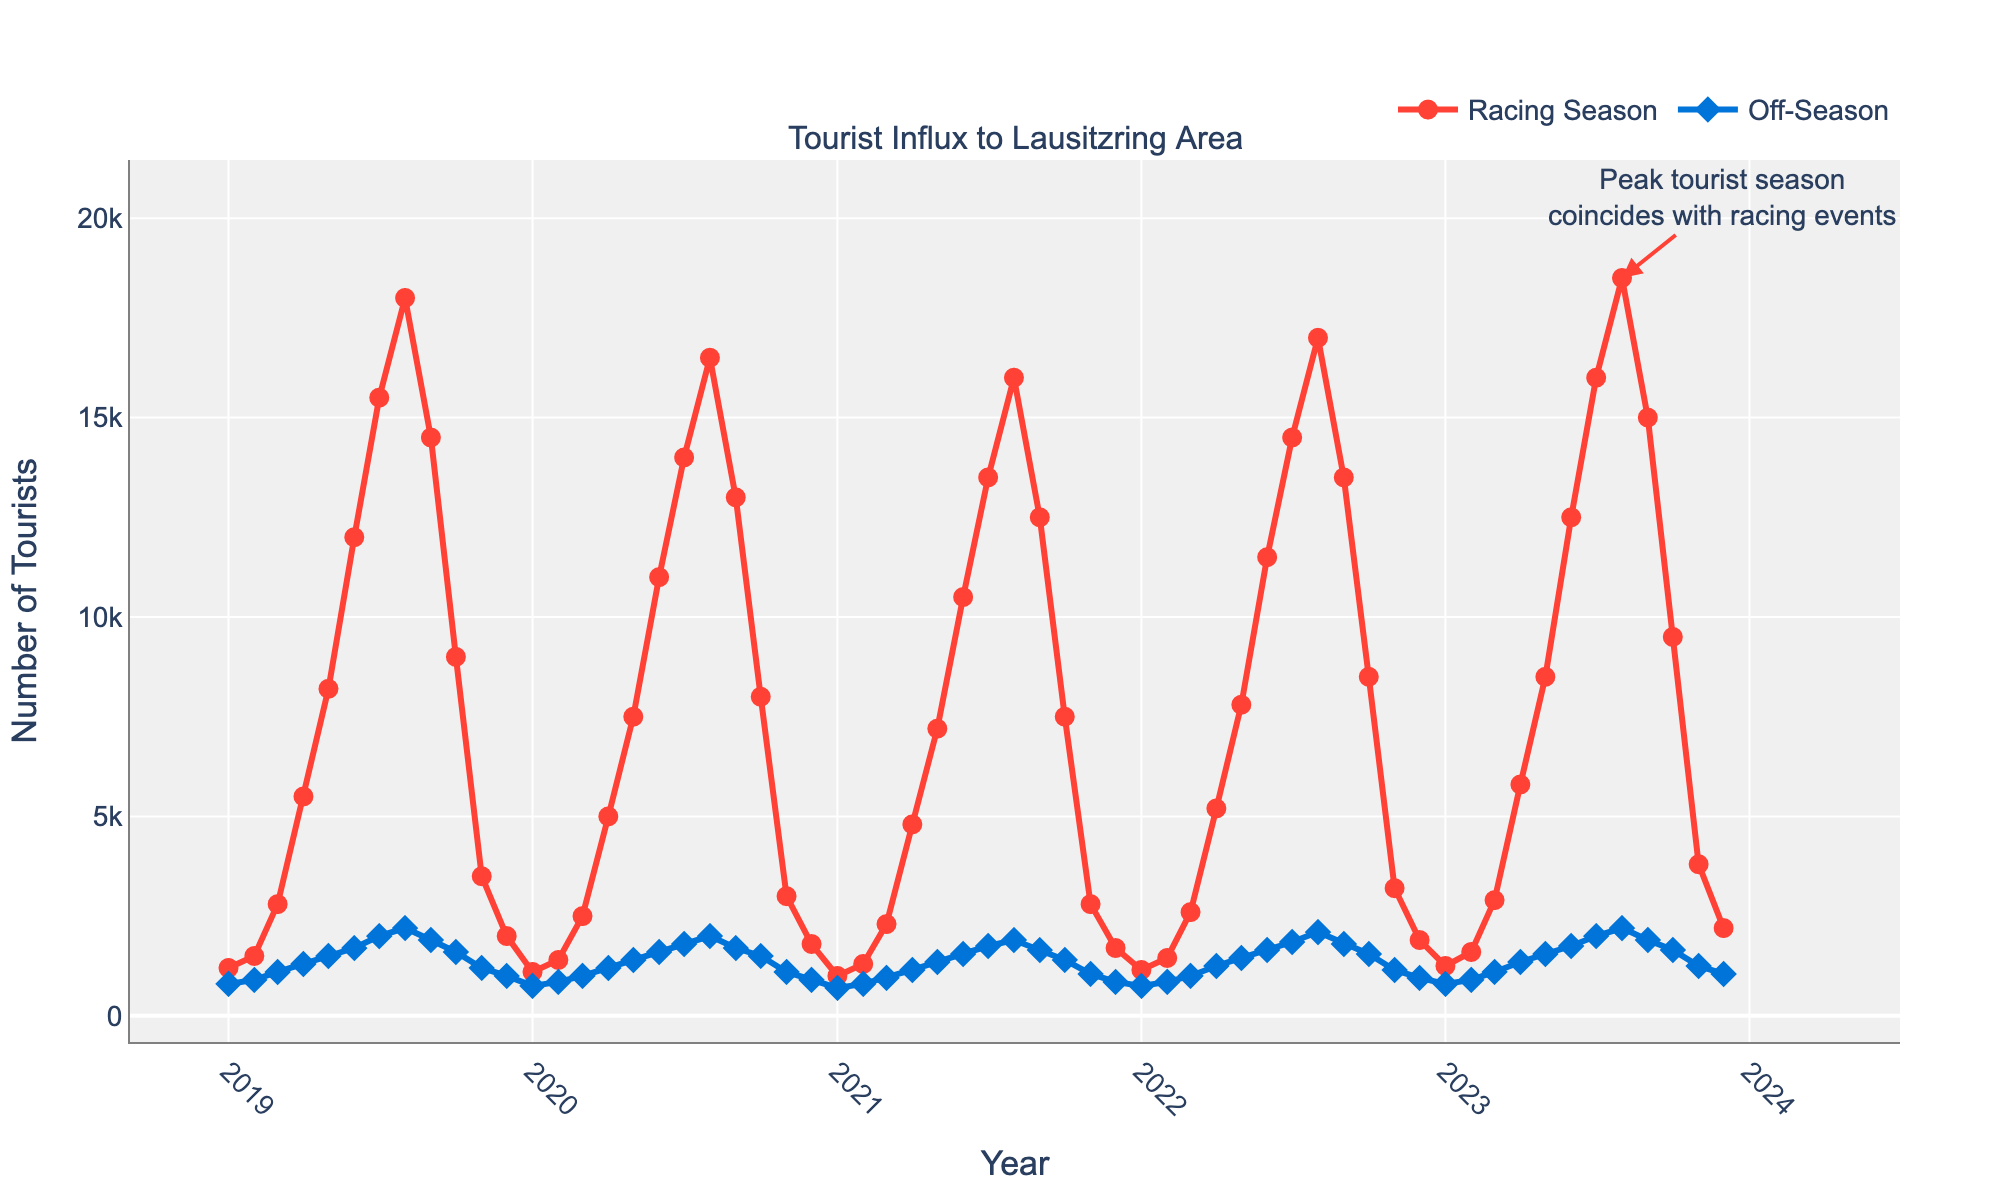Which month had the highest tourist influx during the racing season? Look at the peak point of the red line representing the racing season. The highest point is August 2023.
Answer: August 2023 How does the tourist influx compare between June 2023 and November 2023 in the off-season? Compare the heights of the blue line for June 2023 and November 2023. June 2023 shows approximately 1,750 tourists, while November 2023 shows around 1,250 tourists.
Answer: June 2023 had more tourists On average, how much does the tourist influx increase from off-season to racing season in July? Compare the tourist numbers for July in both the racing season (maximum) and off-season (maximum). The average of the difference for each year: 2019 (15,500 - 2,000), 2020 (14,000 - 1,800), 2021 (13,500 - 1,750), 2022 (14,500 - 1,850), 2023 (16,000 - 2,000). This yields ((13,500 + 12,200 + 11,750+ 12,650+ 14,000)/ 5).
Answer: 12,820 tourists Is there a noticeable trend in the tourist influx during off-season months from 2019 to 2023? Look for patterns in the blue line over time. The off-season sections show a slight upward trend overall, while individual fluctuations exist.
Answer: Slight upward trend Which month shows the smallest difference between racing season and off-season tourist numbers? Check the difference between the red and blue lines for each month. June 2019 to December 2023 has varying differences, but December generally shows the smallest gaps. Calculate the differences and identify the smallest one. December 2020 (1,800 - 900), among others, is the smallest
Answer: December 2020 